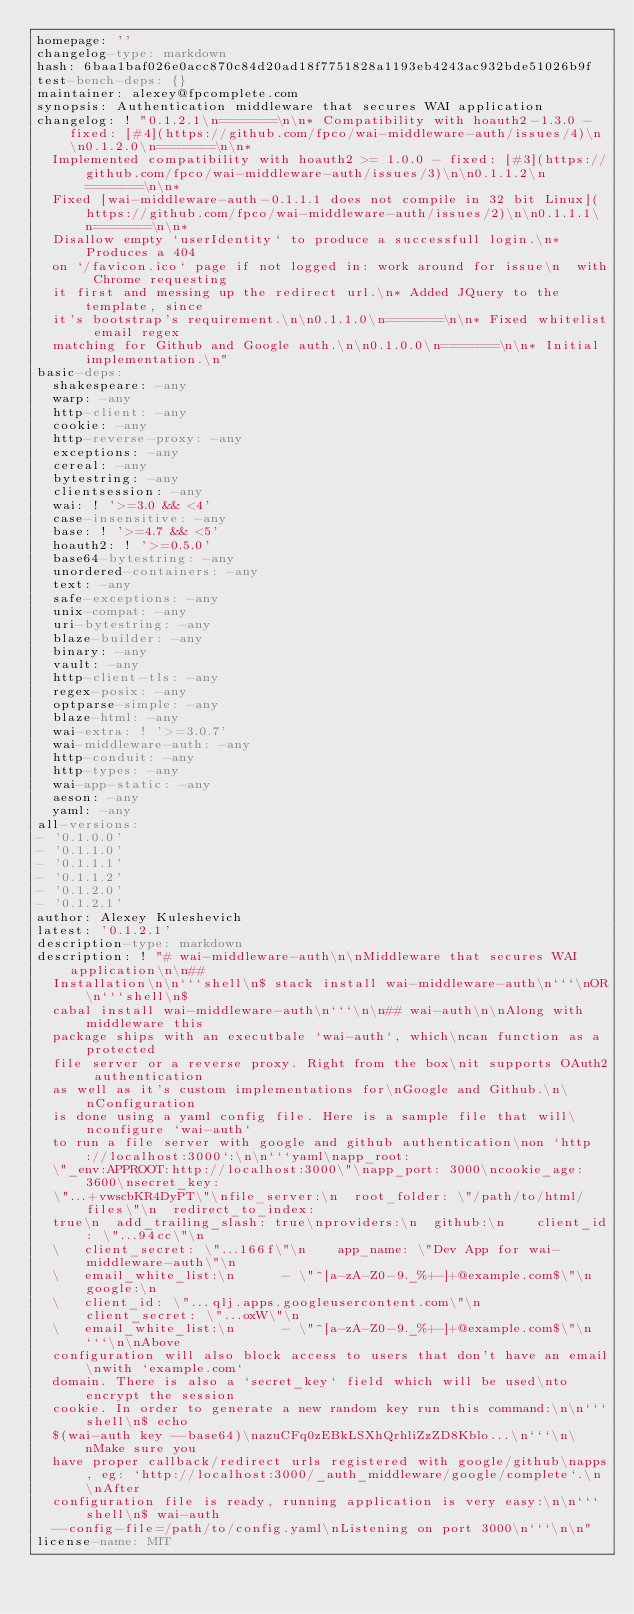<code> <loc_0><loc_0><loc_500><loc_500><_YAML_>homepage: ''
changelog-type: markdown
hash: 6baa1baf026e0acc870c84d20ad18f7751828a1193eb4243ac932bde51026b9f
test-bench-deps: {}
maintainer: alexey@fpcomplete.com
synopsis: Authentication middleware that secures WAI application
changelog: ! "0.1.2.1\n=======\n\n* Compatibility with hoauth2-1.3.0 - fixed: [#4](https://github.com/fpco/wai-middleware-auth/issues/4)\n\n0.1.2.0\n=======\n\n*
  Implemented compatibility with hoauth2 >= 1.0.0 - fixed: [#3](https://github.com/fpco/wai-middleware-auth/issues/3)\n\n0.1.1.2\n=======\n\n*
  Fixed [wai-middleware-auth-0.1.1.1 does not compile in 32 bit Linux](https://github.com/fpco/wai-middleware-auth/issues/2)\n\n0.1.1.1\n=======\n\n*
  Disallow empty `userIdentity` to produce a successfull login.\n* Produces a 404
  on `/favicon.ico` page if not logged in: work around for issue\n  with Chrome requesting
  it first and messing up the redirect url.\n* Added JQuery to the template, since
  it's bootstrap's requirement.\n\n0.1.1.0\n=======\n\n* Fixed whitelist email regex
  matching for Github and Google auth.\n\n0.1.0.0\n=======\n\n* Initial implementation.\n"
basic-deps:
  shakespeare: -any
  warp: -any
  http-client: -any
  cookie: -any
  http-reverse-proxy: -any
  exceptions: -any
  cereal: -any
  bytestring: -any
  clientsession: -any
  wai: ! '>=3.0 && <4'
  case-insensitive: -any
  base: ! '>=4.7 && <5'
  hoauth2: ! '>=0.5.0'
  base64-bytestring: -any
  unordered-containers: -any
  text: -any
  safe-exceptions: -any
  unix-compat: -any
  uri-bytestring: -any
  blaze-builder: -any
  binary: -any
  vault: -any
  http-client-tls: -any
  regex-posix: -any
  optparse-simple: -any
  blaze-html: -any
  wai-extra: ! '>=3.0.7'
  wai-middleware-auth: -any
  http-conduit: -any
  http-types: -any
  wai-app-static: -any
  aeson: -any
  yaml: -any
all-versions:
- '0.1.0.0'
- '0.1.1.0'
- '0.1.1.1'
- '0.1.1.2'
- '0.1.2.0'
- '0.1.2.1'
author: Alexey Kuleshevich
latest: '0.1.2.1'
description-type: markdown
description: ! "# wai-middleware-auth\n\nMiddleware that secures WAI application\n\n##
  Installation\n\n```shell\n$ stack install wai-middleware-auth\n```\nOR\n```shell\n$
  cabal install wai-middleware-auth\n```\n\n## wai-auth\n\nAlong with middleware this
  package ships with an executbale `wai-auth`, which\ncan function as a protected
  file server or a reverse proxy. Right from the box\nit supports OAuth2 authentication
  as well as it's custom implementations for\nGoogle and Github.\n\nConfiguration
  is done using a yaml config file. Here is a sample file that will\nconfigure `wai-auth`
  to run a file server with google and github authentication\non `http://localhost:3000`:\n\n```yaml\napp_root:
  \"_env:APPROOT:http://localhost:3000\"\napp_port: 3000\ncookie_age: 3600\nsecret_key:
  \"...+vwscbKR4DyPT\"\nfile_server:\n  root_folder: \"/path/to/html/files\"\n  redirect_to_index:
  true\n  add_trailing_slash: true\nproviders:\n  github:\n    client_id: \"...94cc\"\n
  \   client_secret: \"...166f\"\n    app_name: \"Dev App for wai-middleware-auth\"\n
  \   email_white_list:\n      - \"^[a-zA-Z0-9._%+-]+@example.com$\"\n  google:\n
  \   client_id: \"...qlj.apps.googleusercontent.com\"\n    client_secret: \"...oxW\"\n
  \   email_white_list:\n      - \"^[a-zA-Z0-9._%+-]+@example.com$\"\n```\n\nAbove
  configuration will also block access to users that don't have an email\nwith `example.com`
  domain. There is also a `secret_key` field which will be used\nto encrypt the session
  cookie. In order to generate a new random key run this command:\n\n```shell\n$ echo
  $(wai-auth key --base64)\nazuCFq0zEBkLSXhQrhliZzZD8Kblo...\n```\n\nMake sure you
  have proper callback/redirect urls registered with google/github\napps, eg: `http://localhost:3000/_auth_middleware/google/complete`.\n\nAfter
  configuration file is ready, running application is very easy:\n\n```shell\n$ wai-auth
  --config-file=/path/to/config.yaml\nListening on port 3000\n```\n\n"
license-name: MIT
</code> 